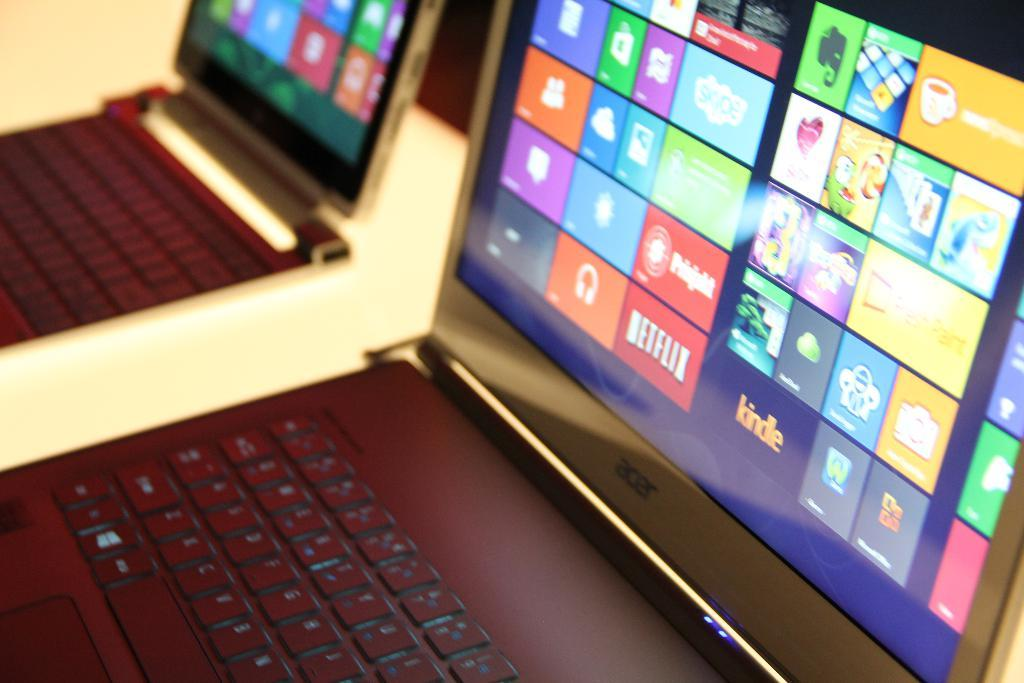<image>
Describe the image concisely. Acer lap top computers on display with colorful icons on their screens 